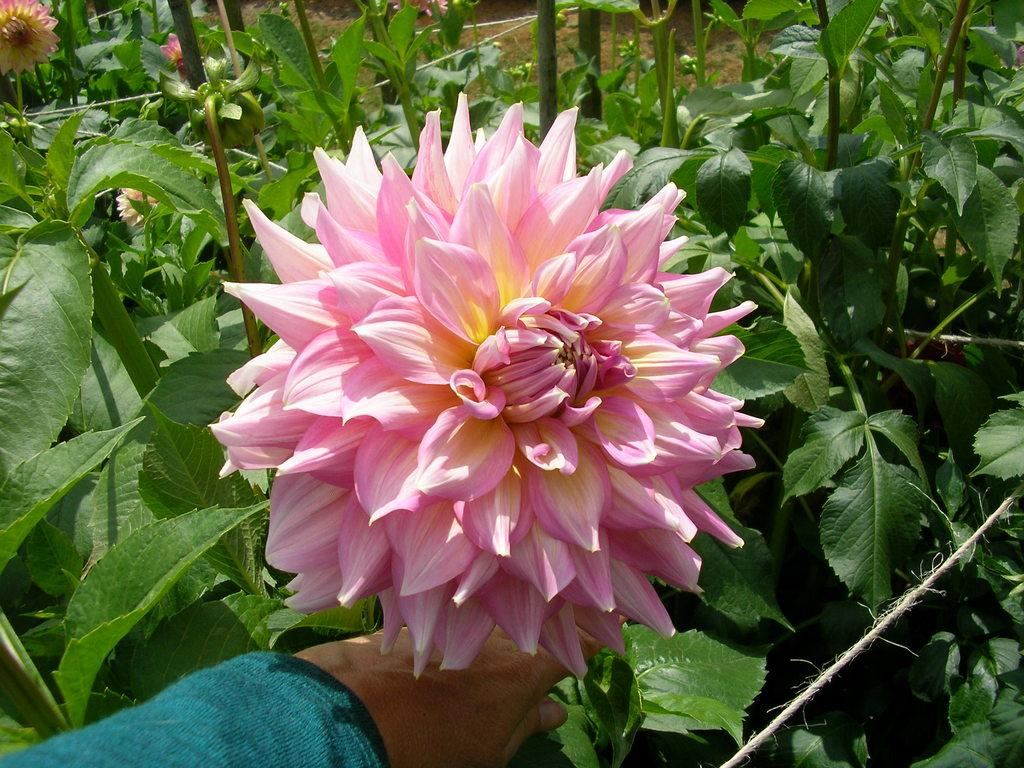What part of a person can be seen in the image? There is a hand of a person in the image. What type of vegetation is present in the image? There are plants in the image. What specific type of plant can be seen in the image? There are flowers in the image. What type of brass instrument is being played by the person in the image? There is no brass instrument or indication of music playing in the image; it only shows a hand and plants. 